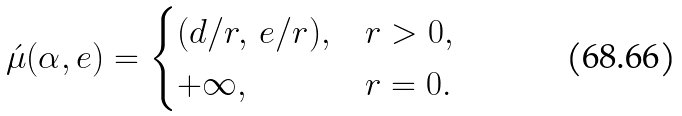<formula> <loc_0><loc_0><loc_500><loc_500>\acute { \mu } ( \alpha , e ) = \begin{cases} ( d / r , \, e / r ) , & r > 0 , \\ + \infty , & r = 0 . \end{cases}</formula> 